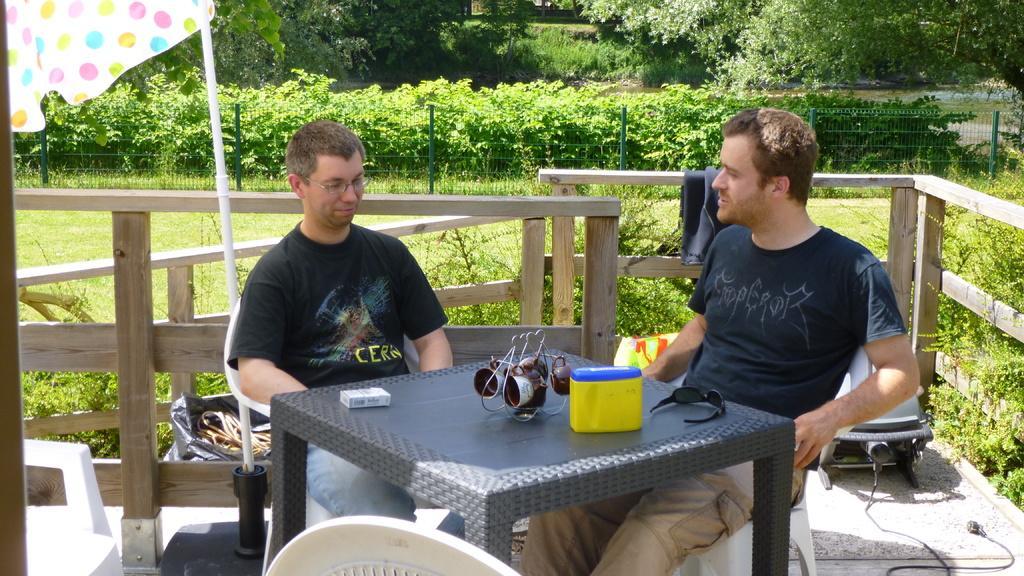In one or two sentences, can you explain what this image depicts? On the background we can see trees and plants. This is a fence. Here we can see few persons sitting on chairs in front of a table. He wore spectacles. On the table we can see a stand and cups hanged over it. This is a box, goggles and a cigarette box. These are chairs. This is a black cover. This is an umbrella. 